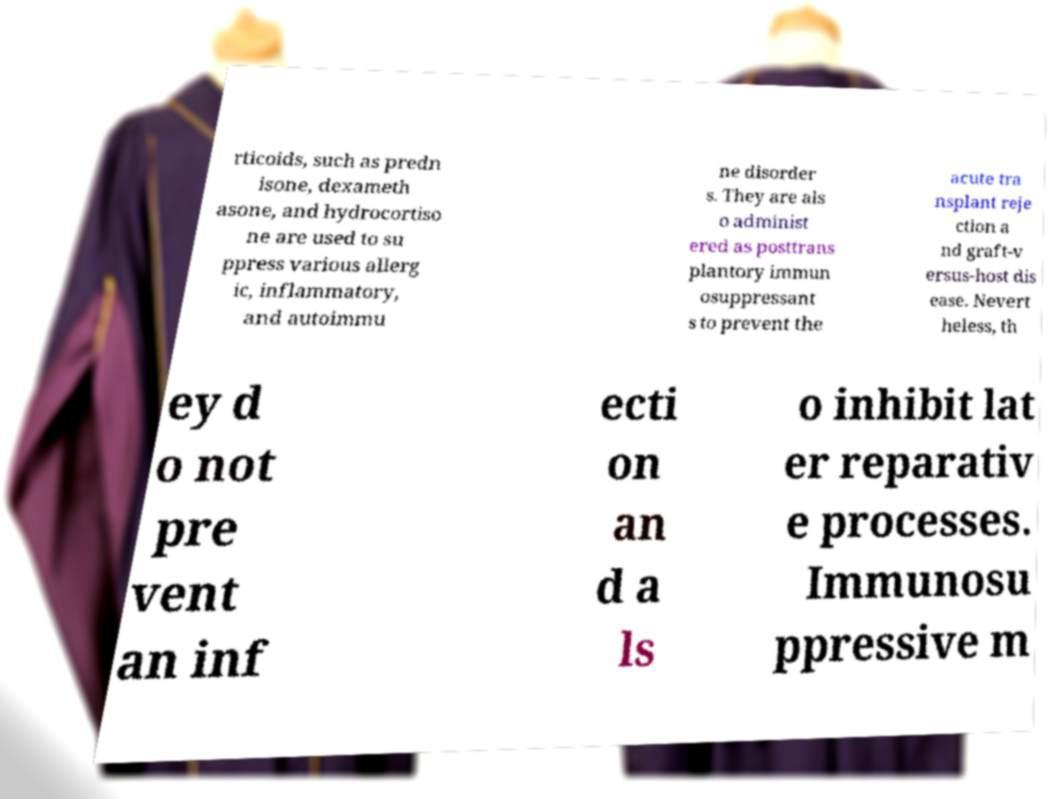Please identify and transcribe the text found in this image. rticoids, such as predn isone, dexameth asone, and hydrocortiso ne are used to su ppress various allerg ic, inflammatory, and autoimmu ne disorder s. They are als o administ ered as posttrans plantory immun osuppressant s to prevent the acute tra nsplant reje ction a nd graft-v ersus-host dis ease. Nevert heless, th ey d o not pre vent an inf ecti on an d a ls o inhibit lat er reparativ e processes. Immunosu ppressive m 